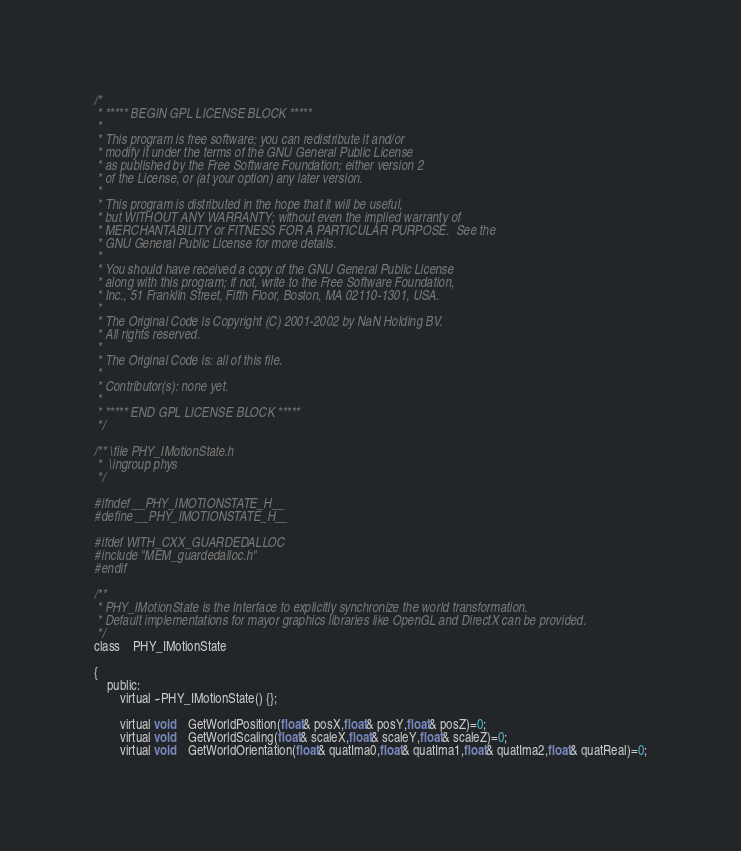<code> <loc_0><loc_0><loc_500><loc_500><_C_>/*
 * ***** BEGIN GPL LICENSE BLOCK *****
 *
 * This program is free software; you can redistribute it and/or
 * modify it under the terms of the GNU General Public License
 * as published by the Free Software Foundation; either version 2
 * of the License, or (at your option) any later version.
 *
 * This program is distributed in the hope that it will be useful,
 * but WITHOUT ANY WARRANTY; without even the implied warranty of
 * MERCHANTABILITY or FITNESS FOR A PARTICULAR PURPOSE.  See the
 * GNU General Public License for more details.
 *
 * You should have received a copy of the GNU General Public License
 * along with this program; if not, write to the Free Software Foundation,
 * Inc., 51 Franklin Street, Fifth Floor, Boston, MA 02110-1301, USA.
 *
 * The Original Code is Copyright (C) 2001-2002 by NaN Holding BV.
 * All rights reserved.
 *
 * The Original Code is: all of this file.
 *
 * Contributor(s): none yet.
 *
 * ***** END GPL LICENSE BLOCK *****
 */

/** \file PHY_IMotionState.h
 *  \ingroup phys
 */

#ifndef __PHY_IMOTIONSTATE_H__
#define __PHY_IMOTIONSTATE_H__

#ifdef WITH_CXX_GUARDEDALLOC
#include "MEM_guardedalloc.h"
#endif

/**
 * PHY_IMotionState is the Interface to explicitly synchronize the world transformation.
 * Default implementations for mayor graphics libraries like OpenGL and DirectX can be provided.
 */
class	PHY_IMotionState

{
	public:
		virtual ~PHY_IMotionState() {};

		virtual void	GetWorldPosition(float& posX,float& posY,float& posZ)=0;
		virtual void	GetWorldScaling(float& scaleX,float& scaleY,float& scaleZ)=0;
		virtual void	GetWorldOrientation(float& quatIma0,float& quatIma1,float& quatIma2,float& quatReal)=0;</code> 